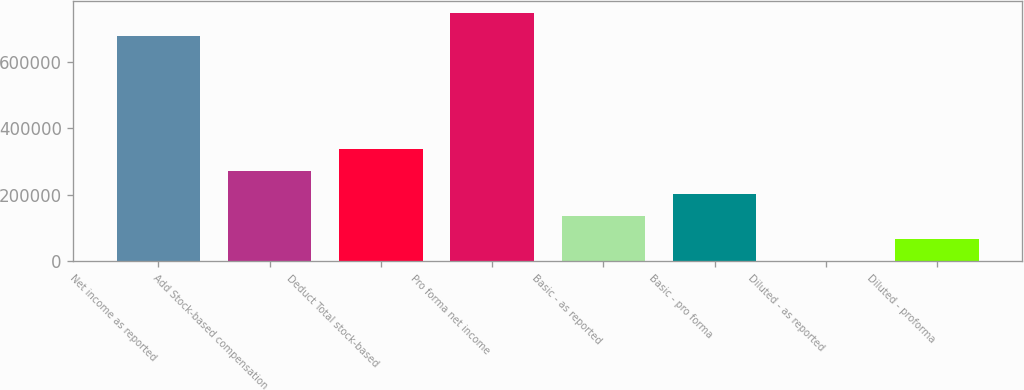Convert chart to OTSL. <chart><loc_0><loc_0><loc_500><loc_500><bar_chart><fcel>Net income as reported<fcel>Add Stock-based compensation<fcel>Deduct Total stock-based<fcel>Pro forma net income<fcel>Basic - as reported<fcel>Basic - pro forma<fcel>Diluted - as reported<fcel>Diluted - proforma<nl><fcel>678428<fcel>271373<fcel>339216<fcel>746270<fcel>135689<fcel>203531<fcel>3.79<fcel>67846.2<nl></chart> 